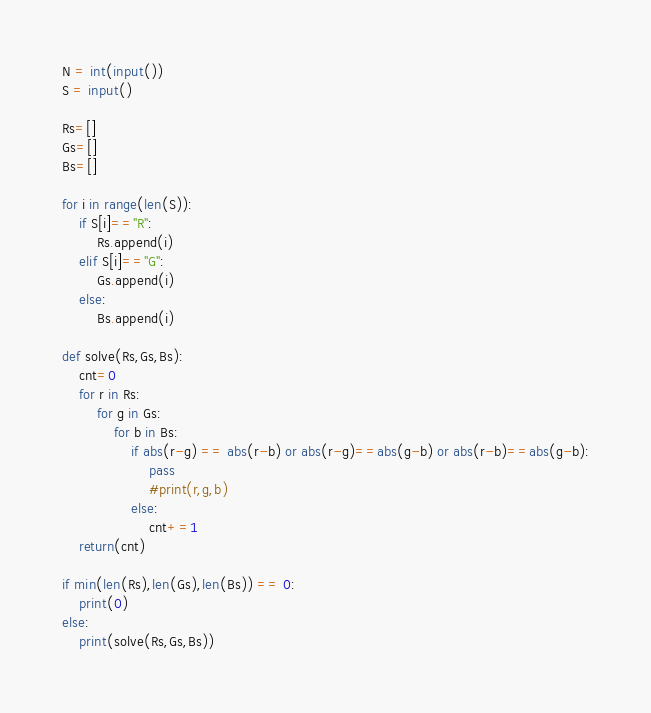Convert code to text. <code><loc_0><loc_0><loc_500><loc_500><_Python_>N = int(input())
S = input()

Rs=[]
Gs=[]
Bs=[]

for i in range(len(S)):
    if S[i]=="R":
        Rs.append(i)
    elif S[i]=="G":
        Gs.append(i)
    else:
        Bs.append(i)

def solve(Rs,Gs,Bs):
    cnt=0
    for r in Rs:
        for g in Gs:
            for b in Bs:
                if abs(r-g) == abs(r-b) or abs(r-g)==abs(g-b) or abs(r-b)==abs(g-b):
                    pass
                    #print(r,g,b)
                else:
                    cnt+=1
    return(cnt)

if min(len(Rs),len(Gs),len(Bs)) == 0:
    print(0)
else:
    print(solve(Rs,Gs,Bs))</code> 